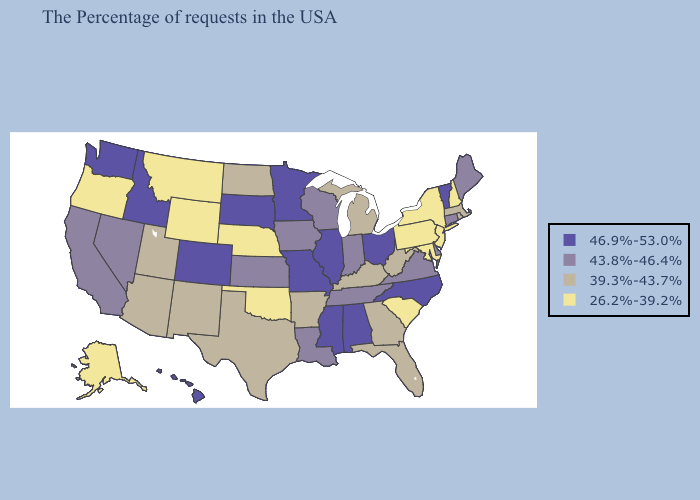What is the lowest value in the West?
Keep it brief. 26.2%-39.2%. Does Alaska have the highest value in the West?
Answer briefly. No. Name the states that have a value in the range 46.9%-53.0%?
Quick response, please. Vermont, North Carolina, Ohio, Alabama, Illinois, Mississippi, Missouri, Minnesota, South Dakota, Colorado, Idaho, Washington, Hawaii. Among the states that border Illinois , does Missouri have the highest value?
Keep it brief. Yes. Among the states that border Nebraska , does Colorado have the highest value?
Keep it brief. Yes. Does Virginia have a higher value than Vermont?
Give a very brief answer. No. Name the states that have a value in the range 43.8%-46.4%?
Be succinct. Maine, Connecticut, Delaware, Virginia, Indiana, Tennessee, Wisconsin, Louisiana, Iowa, Kansas, Nevada, California. What is the value of Florida?
Be succinct. 39.3%-43.7%. Does Louisiana have the same value as Nevada?
Quick response, please. Yes. What is the highest value in the South ?
Write a very short answer. 46.9%-53.0%. Does Mississippi have the highest value in the South?
Short answer required. Yes. Does South Dakota have the lowest value in the USA?
Be succinct. No. Name the states that have a value in the range 39.3%-43.7%?
Keep it brief. Massachusetts, Rhode Island, West Virginia, Florida, Georgia, Michigan, Kentucky, Arkansas, Texas, North Dakota, New Mexico, Utah, Arizona. Name the states that have a value in the range 26.2%-39.2%?
Keep it brief. New Hampshire, New York, New Jersey, Maryland, Pennsylvania, South Carolina, Nebraska, Oklahoma, Wyoming, Montana, Oregon, Alaska. Which states have the lowest value in the USA?
Keep it brief. New Hampshire, New York, New Jersey, Maryland, Pennsylvania, South Carolina, Nebraska, Oklahoma, Wyoming, Montana, Oregon, Alaska. 